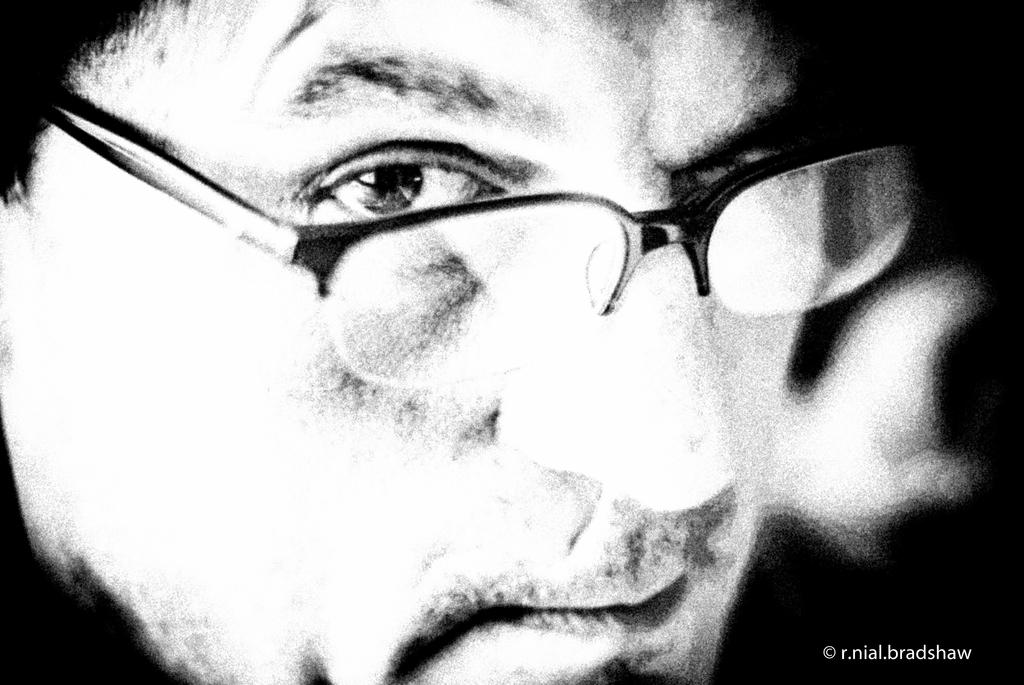What type of editing has been done to the image? The image is edited, but the specific type of editing is not mentioned in the facts. What can be seen on the person's face in the image? The person is wearing spectacles. Where is the watermark located in the image? The watermark is at the bottom right side of the image. What type of juice is the person drinking in the image? There is no juice or drinking activity depicted in the image. How far away is the person from the camera in the image? The distance between the person and the camera is not mentioned in the facts, so it cannot be determined from the image. 